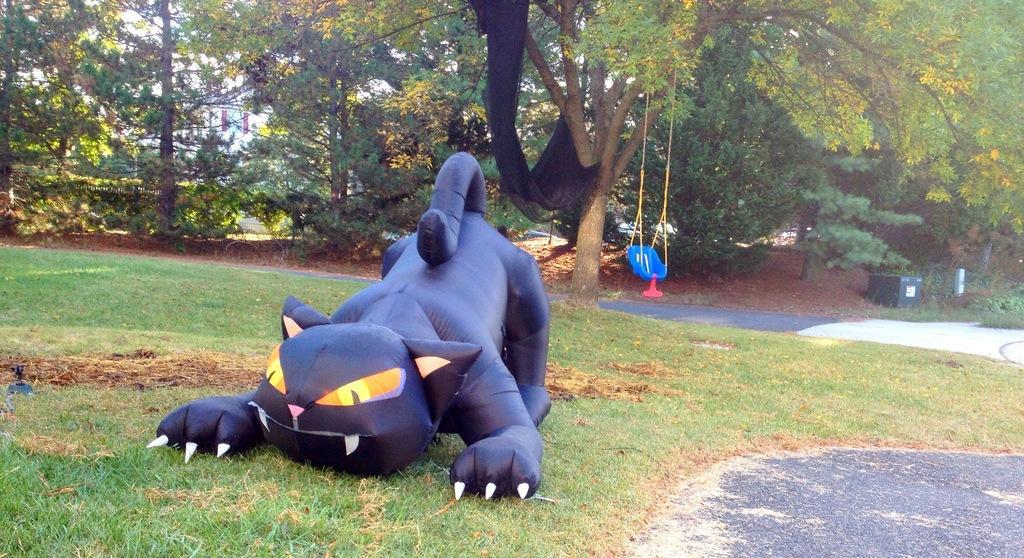How would you summarize this image in a sentence or two? In the center of the image we can see air balloon on the grass. In the background we can see a swing, trees, and a building 